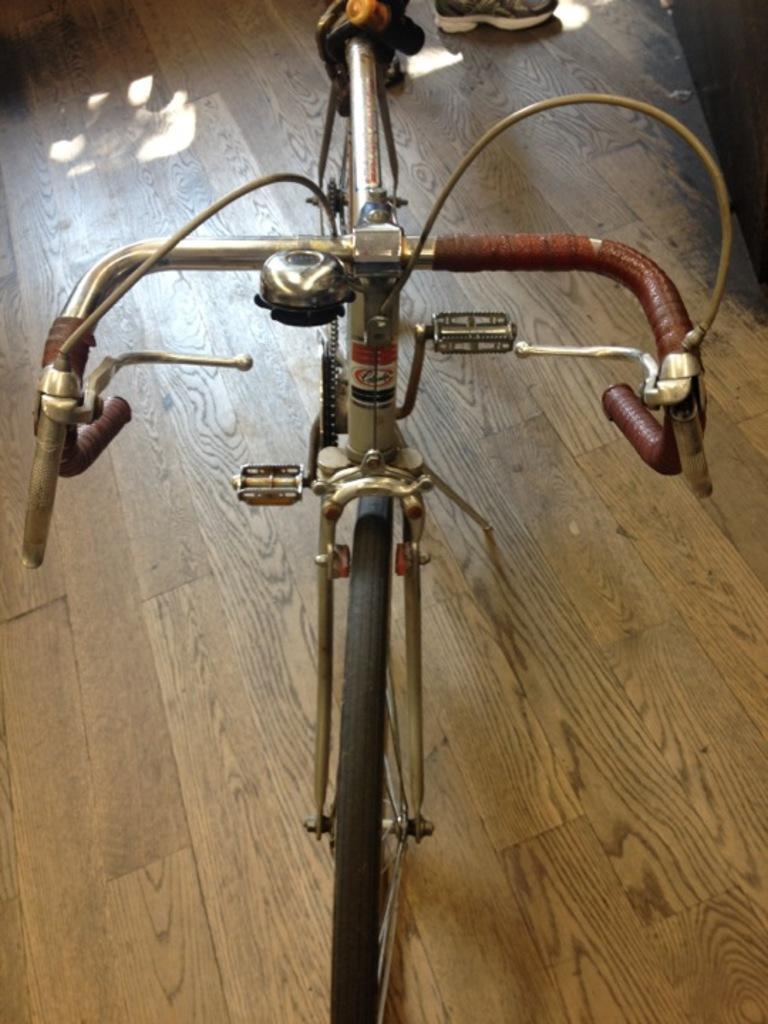Could you give a brief overview of what you see in this image? In this picture there is a bicycle in the foreground. At the back there is a person. At the bottom there is a wooden floor. 